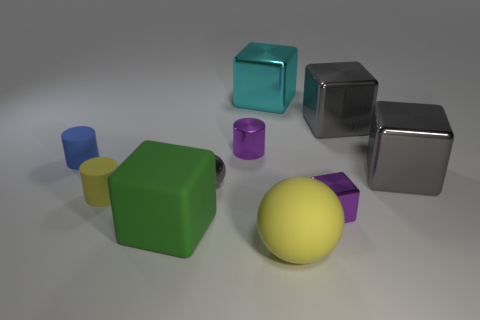Subtract all matte cubes. How many cubes are left? 4 Subtract all green cubes. How many cubes are left? 4 Subtract all red cubes. Subtract all yellow cylinders. How many cubes are left? 5 Subtract all cylinders. How many objects are left? 7 Subtract all gray blocks. Subtract all tiny purple metal cylinders. How many objects are left? 7 Add 3 yellow rubber things. How many yellow rubber things are left? 5 Add 6 gray matte cubes. How many gray matte cubes exist? 6 Subtract 0 cyan cylinders. How many objects are left? 10 